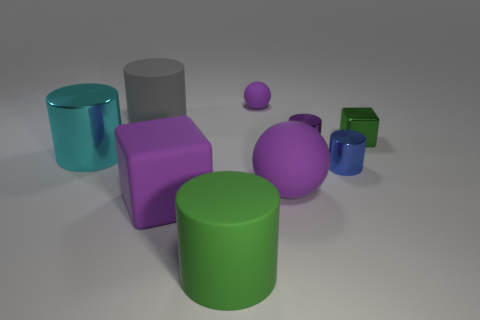Could you guess the approximate size of these objects? Without a reference point for scale, it's tricky to determine the exact size, but given their proportion to each other, they might be similar in size to common household items such as a mug or small box. 